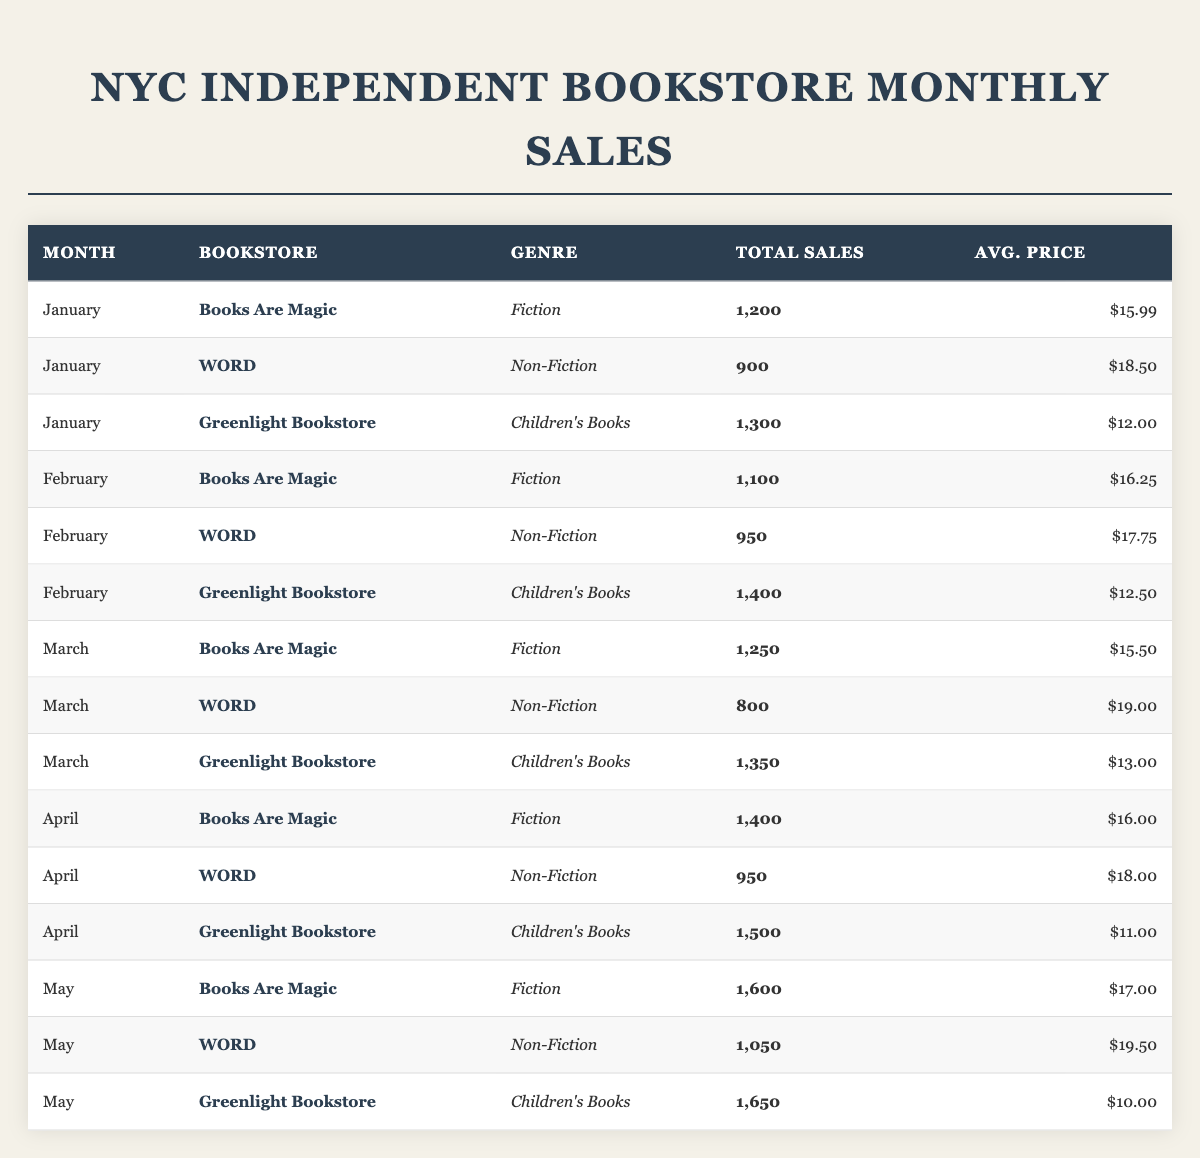What was the total sales for Greenlight Bookstore in February? Referring to the table, Greenlight Bookstore had total sales of 1,400 in February.
Answer: 1,400 Which bookstore had the highest total sales in May? Looking at the May entries, Greenlight Bookstore had total sales of 1,650, which is the highest among the three bookstores.
Answer: Greenlight Bookstore What is the average price of books sold by WORD in January? According to the table, WORD's average price for January is $18.50.
Answer: $18.50 Did Books Are Magic have more total sales in April or May? In April, Books Are Magic had total sales of 1,400, while in May it had 1,600. Since 1,600 > 1,400, May had more sales.
Answer: Yes What is the total sales of Children's Books across all months? Adding up the total sales for Children's Books: 1,300 (January) + 1,400 (February) + 1,350 (March) + 1,500 (April) + 1,650 (May) = 7,200.
Answer: 7,200 Which genre had the lowest average price in April? Reviewing the table, in April, Fiction had an average price of $16.00, Non-Fiction had $18.00, and Children's Books had $11.00. Thus, Children's Books had the lowest average price.
Answer: Children's Books Overall, how many total sales were recorded for WORD from January to May? Summing WORD's total sales from all five months: 900 (Jan) + 950 (Feb) + 800 (Mar) + 950 (Apr) + 1,050 (May) = 4,650.
Answer: 4,650 Is it true that Greenlight Bookstore sold more books in March than in January? Checking the total sales, Greenlight Bookstore sold 1,350 in March and 1,300 in January, which means it's true since 1,350 > 1,300.
Answer: Yes What is the monthly trend of total sales for Books Are Magic from January to May? The total sales for Books Are Magic were: 1,200 (Jan), 1,100 (Feb), 1,250 (Mar), 1,400 (Apr), and 1,600 (May). The trend indicates that sales increased every month after January.
Answer: Increasing Calculate the average sales for all bookstores in January. The total sales for January are 1,200 (Books Are Magic) + 900 (WORD) + 1,300 (Greenlight) = 3,400. There are 3 bookstores, so average = 3,400 / 3 = 1,133.33.
Answer: 1,133.33 